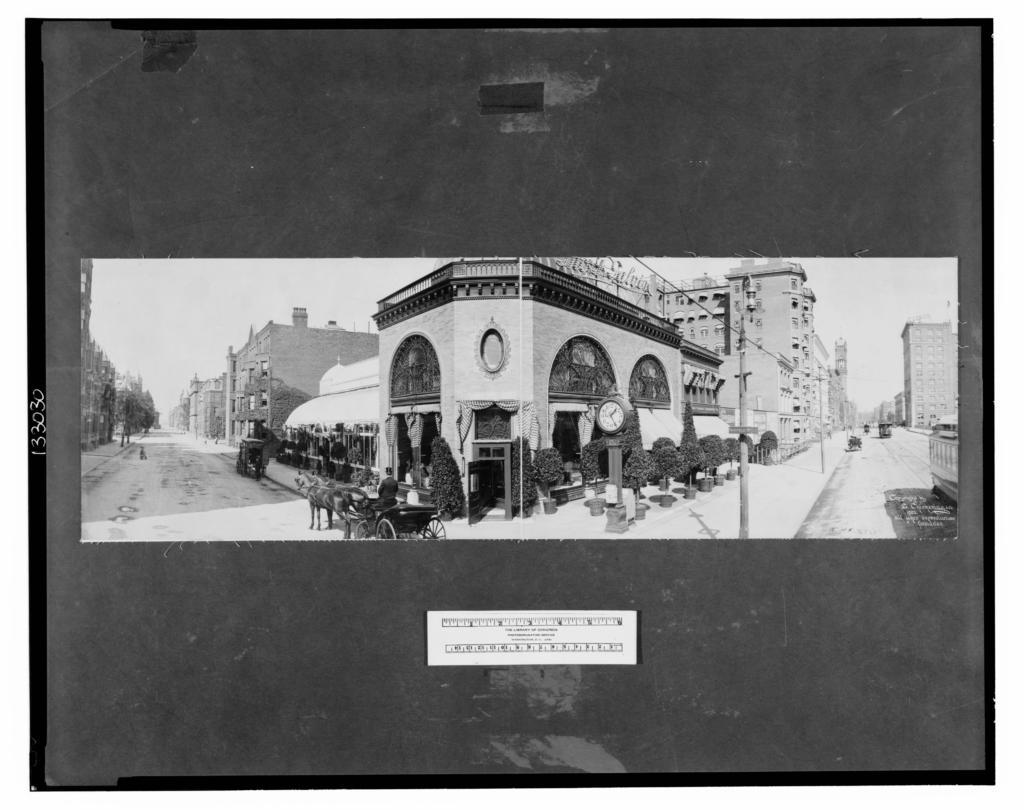What is the color scheme of the image? The image is black and white. What type of structures can be seen in the image? There are buildings in the image. What other natural elements are present in the image? There are trees in the image. What man-made objects can be seen in the image? There are poles and wires in the image. What is happening on the road in the image? There are vehicles moving on the road in the image. What mode of transportation is unique in the image? There is a horse cart in the image. What can be seen in the background of the image? The sky is visible in the background of the image. Where is the apple tree in the image? There is no apple tree present in the image. How many family members can be seen in the image? There is no family depicted in the image. 